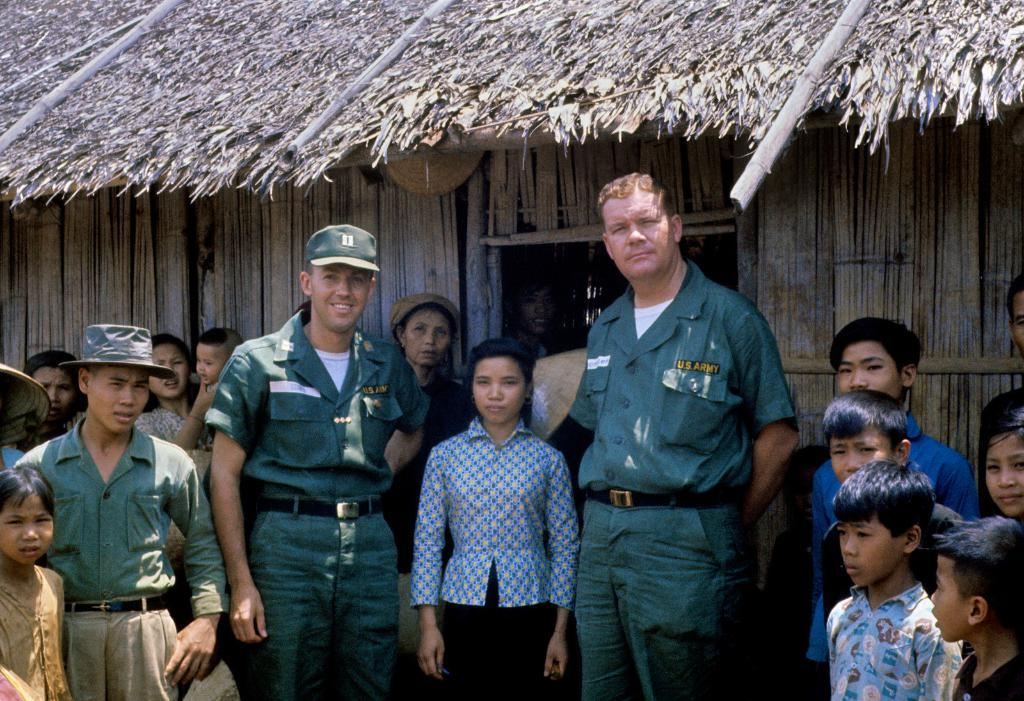What type of house is in the picture? There is a wooden house in the picture. How is the roof of the house constructed? The roof of the house is covered with dried grass and bamboos. What can be seen near the house? There are children near the house, and two men are standing near the house, wearing uniforms. What type of hook is hanging from the roof of the house in the image? There is no hook visible on the roof of the house in the image. 